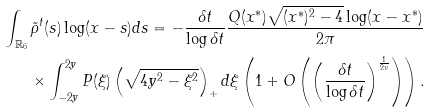<formula> <loc_0><loc_0><loc_500><loc_500>\int _ { \mathbb { R } _ { 6 } } \tilde { \rho } ^ { t } ( s ) \log ( x - s ) d s = - \frac { \delta t } { \log \delta t } \frac { Q ( x ^ { \ast } ) \sqrt { ( x ^ { \ast } ) ^ { 2 } - 4 } \log ( x - x ^ { \ast } ) } { 2 \pi } \\ \times \int _ { - 2 y } ^ { 2 y } P ( \xi ) \left ( \sqrt { 4 y ^ { 2 } - \xi ^ { 2 } } \right ) _ { + } d \xi \left ( 1 + O \left ( \left ( \frac { \delta t } { \log \delta t } \right ) ^ { \frac { 1 } { 2 \nu } } \right ) \right ) .</formula> 